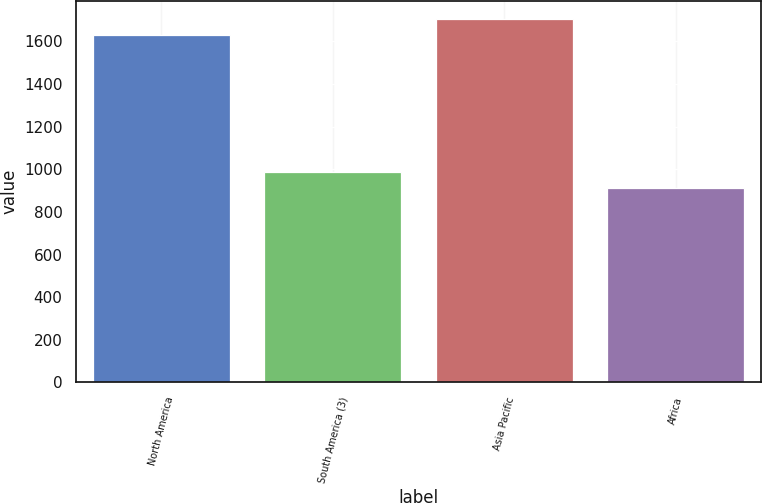<chart> <loc_0><loc_0><loc_500><loc_500><bar_chart><fcel>North America<fcel>South America (3)<fcel>Asia Pacific<fcel>Africa<nl><fcel>1631<fcel>986.6<fcel>1703.6<fcel>914<nl></chart> 